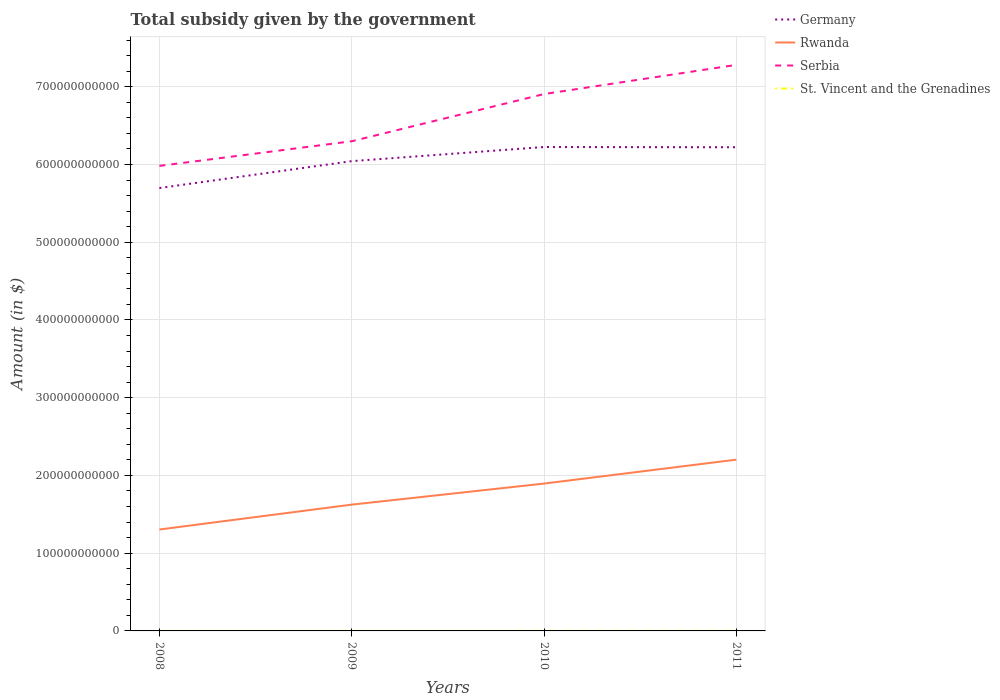How many different coloured lines are there?
Make the answer very short. 4. Does the line corresponding to Rwanda intersect with the line corresponding to Serbia?
Your answer should be very brief. No. Is the number of lines equal to the number of legend labels?
Offer a terse response. Yes. Across all years, what is the maximum total revenue collected by the government in St. Vincent and the Grenadines?
Your answer should be very brief. 8.62e+07. What is the total total revenue collected by the government in St. Vincent and the Grenadines in the graph?
Ensure brevity in your answer.  -2.29e+07. What is the difference between the highest and the second highest total revenue collected by the government in Rwanda?
Your response must be concise. 8.99e+1. What is the difference between the highest and the lowest total revenue collected by the government in Germany?
Your answer should be compact. 2. Is the total revenue collected by the government in Rwanda strictly greater than the total revenue collected by the government in St. Vincent and the Grenadines over the years?
Provide a short and direct response. No. How many lines are there?
Ensure brevity in your answer.  4. What is the difference between two consecutive major ticks on the Y-axis?
Your response must be concise. 1.00e+11. Are the values on the major ticks of Y-axis written in scientific E-notation?
Your answer should be very brief. No. Where does the legend appear in the graph?
Provide a succinct answer. Top right. How are the legend labels stacked?
Your response must be concise. Vertical. What is the title of the graph?
Your answer should be compact. Total subsidy given by the government. What is the label or title of the X-axis?
Offer a terse response. Years. What is the label or title of the Y-axis?
Offer a very short reply. Amount (in $). What is the Amount (in $) in Germany in 2008?
Your answer should be compact. 5.70e+11. What is the Amount (in $) in Rwanda in 2008?
Offer a terse response. 1.30e+11. What is the Amount (in $) of Serbia in 2008?
Your answer should be compact. 5.98e+11. What is the Amount (in $) in St. Vincent and the Grenadines in 2008?
Your answer should be compact. 8.62e+07. What is the Amount (in $) in Germany in 2009?
Provide a short and direct response. 6.04e+11. What is the Amount (in $) of Rwanda in 2009?
Give a very brief answer. 1.62e+11. What is the Amount (in $) in Serbia in 2009?
Offer a terse response. 6.30e+11. What is the Amount (in $) of St. Vincent and the Grenadines in 2009?
Your response must be concise. 1.21e+08. What is the Amount (in $) of Germany in 2010?
Ensure brevity in your answer.  6.22e+11. What is the Amount (in $) of Rwanda in 2010?
Give a very brief answer. 1.90e+11. What is the Amount (in $) in Serbia in 2010?
Your answer should be compact. 6.91e+11. What is the Amount (in $) of St. Vincent and the Grenadines in 2010?
Your answer should be compact. 1.32e+08. What is the Amount (in $) in Germany in 2011?
Ensure brevity in your answer.  6.22e+11. What is the Amount (in $) in Rwanda in 2011?
Keep it short and to the point. 2.20e+11. What is the Amount (in $) in Serbia in 2011?
Provide a short and direct response. 7.28e+11. What is the Amount (in $) in St. Vincent and the Grenadines in 2011?
Give a very brief answer. 1.44e+08. Across all years, what is the maximum Amount (in $) of Germany?
Provide a short and direct response. 6.22e+11. Across all years, what is the maximum Amount (in $) of Rwanda?
Make the answer very short. 2.20e+11. Across all years, what is the maximum Amount (in $) of Serbia?
Ensure brevity in your answer.  7.28e+11. Across all years, what is the maximum Amount (in $) in St. Vincent and the Grenadines?
Ensure brevity in your answer.  1.44e+08. Across all years, what is the minimum Amount (in $) in Germany?
Make the answer very short. 5.70e+11. Across all years, what is the minimum Amount (in $) in Rwanda?
Your response must be concise. 1.30e+11. Across all years, what is the minimum Amount (in $) in Serbia?
Your answer should be very brief. 5.98e+11. Across all years, what is the minimum Amount (in $) of St. Vincent and the Grenadines?
Ensure brevity in your answer.  8.62e+07. What is the total Amount (in $) in Germany in the graph?
Provide a short and direct response. 2.42e+12. What is the total Amount (in $) of Rwanda in the graph?
Your answer should be compact. 7.03e+11. What is the total Amount (in $) in Serbia in the graph?
Offer a terse response. 2.65e+12. What is the total Amount (in $) of St. Vincent and the Grenadines in the graph?
Offer a terse response. 4.82e+08. What is the difference between the Amount (in $) in Germany in 2008 and that in 2009?
Provide a succinct answer. -3.46e+1. What is the difference between the Amount (in $) in Rwanda in 2008 and that in 2009?
Your response must be concise. -3.20e+1. What is the difference between the Amount (in $) in Serbia in 2008 and that in 2009?
Provide a succinct answer. -3.17e+1. What is the difference between the Amount (in $) of St. Vincent and the Grenadines in 2008 and that in 2009?
Ensure brevity in your answer.  -3.45e+07. What is the difference between the Amount (in $) in Germany in 2008 and that in 2010?
Provide a succinct answer. -5.28e+1. What is the difference between the Amount (in $) of Rwanda in 2008 and that in 2010?
Offer a very short reply. -5.91e+1. What is the difference between the Amount (in $) in Serbia in 2008 and that in 2010?
Ensure brevity in your answer.  -9.24e+1. What is the difference between the Amount (in $) of St. Vincent and the Grenadines in 2008 and that in 2010?
Offer a terse response. -4.57e+07. What is the difference between the Amount (in $) in Germany in 2008 and that in 2011?
Provide a short and direct response. -5.25e+1. What is the difference between the Amount (in $) of Rwanda in 2008 and that in 2011?
Keep it short and to the point. -8.99e+1. What is the difference between the Amount (in $) in Serbia in 2008 and that in 2011?
Offer a very short reply. -1.30e+11. What is the difference between the Amount (in $) in St. Vincent and the Grenadines in 2008 and that in 2011?
Ensure brevity in your answer.  -5.74e+07. What is the difference between the Amount (in $) in Germany in 2009 and that in 2010?
Make the answer very short. -1.82e+1. What is the difference between the Amount (in $) of Rwanda in 2009 and that in 2010?
Offer a terse response. -2.71e+1. What is the difference between the Amount (in $) of Serbia in 2009 and that in 2010?
Your answer should be compact. -6.07e+1. What is the difference between the Amount (in $) in St. Vincent and the Grenadines in 2009 and that in 2010?
Give a very brief answer. -1.12e+07. What is the difference between the Amount (in $) of Germany in 2009 and that in 2011?
Ensure brevity in your answer.  -1.79e+1. What is the difference between the Amount (in $) in Rwanda in 2009 and that in 2011?
Your answer should be very brief. -5.79e+1. What is the difference between the Amount (in $) of Serbia in 2009 and that in 2011?
Provide a succinct answer. -9.83e+1. What is the difference between the Amount (in $) in St. Vincent and the Grenadines in 2009 and that in 2011?
Provide a succinct answer. -2.29e+07. What is the difference between the Amount (in $) of Germany in 2010 and that in 2011?
Make the answer very short. 3.00e+08. What is the difference between the Amount (in $) of Rwanda in 2010 and that in 2011?
Provide a short and direct response. -3.08e+1. What is the difference between the Amount (in $) in Serbia in 2010 and that in 2011?
Keep it short and to the point. -3.75e+1. What is the difference between the Amount (in $) of St. Vincent and the Grenadines in 2010 and that in 2011?
Offer a very short reply. -1.17e+07. What is the difference between the Amount (in $) in Germany in 2008 and the Amount (in $) in Rwanda in 2009?
Your response must be concise. 4.07e+11. What is the difference between the Amount (in $) in Germany in 2008 and the Amount (in $) in Serbia in 2009?
Your response must be concise. -6.02e+1. What is the difference between the Amount (in $) in Germany in 2008 and the Amount (in $) in St. Vincent and the Grenadines in 2009?
Your answer should be very brief. 5.70e+11. What is the difference between the Amount (in $) of Rwanda in 2008 and the Amount (in $) of Serbia in 2009?
Offer a very short reply. -4.99e+11. What is the difference between the Amount (in $) in Rwanda in 2008 and the Amount (in $) in St. Vincent and the Grenadines in 2009?
Ensure brevity in your answer.  1.30e+11. What is the difference between the Amount (in $) of Serbia in 2008 and the Amount (in $) of St. Vincent and the Grenadines in 2009?
Make the answer very short. 5.98e+11. What is the difference between the Amount (in $) in Germany in 2008 and the Amount (in $) in Rwanda in 2010?
Offer a very short reply. 3.80e+11. What is the difference between the Amount (in $) of Germany in 2008 and the Amount (in $) of Serbia in 2010?
Your answer should be very brief. -1.21e+11. What is the difference between the Amount (in $) in Germany in 2008 and the Amount (in $) in St. Vincent and the Grenadines in 2010?
Your response must be concise. 5.70e+11. What is the difference between the Amount (in $) in Rwanda in 2008 and the Amount (in $) in Serbia in 2010?
Offer a very short reply. -5.60e+11. What is the difference between the Amount (in $) of Rwanda in 2008 and the Amount (in $) of St. Vincent and the Grenadines in 2010?
Your response must be concise. 1.30e+11. What is the difference between the Amount (in $) of Serbia in 2008 and the Amount (in $) of St. Vincent and the Grenadines in 2010?
Your answer should be very brief. 5.98e+11. What is the difference between the Amount (in $) in Germany in 2008 and the Amount (in $) in Rwanda in 2011?
Provide a short and direct response. 3.49e+11. What is the difference between the Amount (in $) of Germany in 2008 and the Amount (in $) of Serbia in 2011?
Your answer should be very brief. -1.58e+11. What is the difference between the Amount (in $) of Germany in 2008 and the Amount (in $) of St. Vincent and the Grenadines in 2011?
Your answer should be very brief. 5.70e+11. What is the difference between the Amount (in $) in Rwanda in 2008 and the Amount (in $) in Serbia in 2011?
Ensure brevity in your answer.  -5.98e+11. What is the difference between the Amount (in $) in Rwanda in 2008 and the Amount (in $) in St. Vincent and the Grenadines in 2011?
Make the answer very short. 1.30e+11. What is the difference between the Amount (in $) of Serbia in 2008 and the Amount (in $) of St. Vincent and the Grenadines in 2011?
Ensure brevity in your answer.  5.98e+11. What is the difference between the Amount (in $) of Germany in 2009 and the Amount (in $) of Rwanda in 2010?
Keep it short and to the point. 4.15e+11. What is the difference between the Amount (in $) of Germany in 2009 and the Amount (in $) of Serbia in 2010?
Provide a short and direct response. -8.63e+1. What is the difference between the Amount (in $) in Germany in 2009 and the Amount (in $) in St. Vincent and the Grenadines in 2010?
Keep it short and to the point. 6.04e+11. What is the difference between the Amount (in $) in Rwanda in 2009 and the Amount (in $) in Serbia in 2010?
Provide a short and direct response. -5.28e+11. What is the difference between the Amount (in $) in Rwanda in 2009 and the Amount (in $) in St. Vincent and the Grenadines in 2010?
Give a very brief answer. 1.62e+11. What is the difference between the Amount (in $) of Serbia in 2009 and the Amount (in $) of St. Vincent and the Grenadines in 2010?
Give a very brief answer. 6.30e+11. What is the difference between the Amount (in $) in Germany in 2009 and the Amount (in $) in Rwanda in 2011?
Offer a very short reply. 3.84e+11. What is the difference between the Amount (in $) in Germany in 2009 and the Amount (in $) in Serbia in 2011?
Keep it short and to the point. -1.24e+11. What is the difference between the Amount (in $) in Germany in 2009 and the Amount (in $) in St. Vincent and the Grenadines in 2011?
Keep it short and to the point. 6.04e+11. What is the difference between the Amount (in $) in Rwanda in 2009 and the Amount (in $) in Serbia in 2011?
Offer a very short reply. -5.66e+11. What is the difference between the Amount (in $) of Rwanda in 2009 and the Amount (in $) of St. Vincent and the Grenadines in 2011?
Your answer should be compact. 1.62e+11. What is the difference between the Amount (in $) of Serbia in 2009 and the Amount (in $) of St. Vincent and the Grenadines in 2011?
Your answer should be compact. 6.30e+11. What is the difference between the Amount (in $) in Germany in 2010 and the Amount (in $) in Rwanda in 2011?
Your response must be concise. 4.02e+11. What is the difference between the Amount (in $) of Germany in 2010 and the Amount (in $) of Serbia in 2011?
Provide a short and direct response. -1.06e+11. What is the difference between the Amount (in $) of Germany in 2010 and the Amount (in $) of St. Vincent and the Grenadines in 2011?
Keep it short and to the point. 6.22e+11. What is the difference between the Amount (in $) in Rwanda in 2010 and the Amount (in $) in Serbia in 2011?
Your answer should be very brief. -5.39e+11. What is the difference between the Amount (in $) of Rwanda in 2010 and the Amount (in $) of St. Vincent and the Grenadines in 2011?
Offer a very short reply. 1.89e+11. What is the difference between the Amount (in $) in Serbia in 2010 and the Amount (in $) in St. Vincent and the Grenadines in 2011?
Your answer should be compact. 6.90e+11. What is the average Amount (in $) in Germany per year?
Keep it short and to the point. 6.05e+11. What is the average Amount (in $) in Rwanda per year?
Offer a very short reply. 1.76e+11. What is the average Amount (in $) of Serbia per year?
Offer a terse response. 6.62e+11. What is the average Amount (in $) of St. Vincent and the Grenadines per year?
Your answer should be very brief. 1.21e+08. In the year 2008, what is the difference between the Amount (in $) in Germany and Amount (in $) in Rwanda?
Offer a very short reply. 4.39e+11. In the year 2008, what is the difference between the Amount (in $) in Germany and Amount (in $) in Serbia?
Your answer should be compact. -2.85e+1. In the year 2008, what is the difference between the Amount (in $) in Germany and Amount (in $) in St. Vincent and the Grenadines?
Your response must be concise. 5.70e+11. In the year 2008, what is the difference between the Amount (in $) in Rwanda and Amount (in $) in Serbia?
Keep it short and to the point. -4.68e+11. In the year 2008, what is the difference between the Amount (in $) of Rwanda and Amount (in $) of St. Vincent and the Grenadines?
Offer a terse response. 1.30e+11. In the year 2008, what is the difference between the Amount (in $) of Serbia and Amount (in $) of St. Vincent and the Grenadines?
Keep it short and to the point. 5.98e+11. In the year 2009, what is the difference between the Amount (in $) of Germany and Amount (in $) of Rwanda?
Make the answer very short. 4.42e+11. In the year 2009, what is the difference between the Amount (in $) of Germany and Amount (in $) of Serbia?
Provide a succinct answer. -2.56e+1. In the year 2009, what is the difference between the Amount (in $) in Germany and Amount (in $) in St. Vincent and the Grenadines?
Your response must be concise. 6.04e+11. In the year 2009, what is the difference between the Amount (in $) of Rwanda and Amount (in $) of Serbia?
Keep it short and to the point. -4.67e+11. In the year 2009, what is the difference between the Amount (in $) of Rwanda and Amount (in $) of St. Vincent and the Grenadines?
Give a very brief answer. 1.62e+11. In the year 2009, what is the difference between the Amount (in $) of Serbia and Amount (in $) of St. Vincent and the Grenadines?
Offer a terse response. 6.30e+11. In the year 2010, what is the difference between the Amount (in $) in Germany and Amount (in $) in Rwanda?
Ensure brevity in your answer.  4.33e+11. In the year 2010, what is the difference between the Amount (in $) of Germany and Amount (in $) of Serbia?
Your answer should be compact. -6.81e+1. In the year 2010, what is the difference between the Amount (in $) of Germany and Amount (in $) of St. Vincent and the Grenadines?
Offer a terse response. 6.22e+11. In the year 2010, what is the difference between the Amount (in $) of Rwanda and Amount (in $) of Serbia?
Ensure brevity in your answer.  -5.01e+11. In the year 2010, what is the difference between the Amount (in $) of Rwanda and Amount (in $) of St. Vincent and the Grenadines?
Your answer should be very brief. 1.89e+11. In the year 2010, what is the difference between the Amount (in $) in Serbia and Amount (in $) in St. Vincent and the Grenadines?
Your answer should be very brief. 6.90e+11. In the year 2011, what is the difference between the Amount (in $) in Germany and Amount (in $) in Rwanda?
Provide a short and direct response. 4.02e+11. In the year 2011, what is the difference between the Amount (in $) in Germany and Amount (in $) in Serbia?
Your answer should be compact. -1.06e+11. In the year 2011, what is the difference between the Amount (in $) in Germany and Amount (in $) in St. Vincent and the Grenadines?
Offer a terse response. 6.22e+11. In the year 2011, what is the difference between the Amount (in $) of Rwanda and Amount (in $) of Serbia?
Offer a very short reply. -5.08e+11. In the year 2011, what is the difference between the Amount (in $) in Rwanda and Amount (in $) in St. Vincent and the Grenadines?
Make the answer very short. 2.20e+11. In the year 2011, what is the difference between the Amount (in $) in Serbia and Amount (in $) in St. Vincent and the Grenadines?
Your answer should be very brief. 7.28e+11. What is the ratio of the Amount (in $) in Germany in 2008 to that in 2009?
Give a very brief answer. 0.94. What is the ratio of the Amount (in $) in Rwanda in 2008 to that in 2009?
Keep it short and to the point. 0.8. What is the ratio of the Amount (in $) of Serbia in 2008 to that in 2009?
Your answer should be compact. 0.95. What is the ratio of the Amount (in $) in St. Vincent and the Grenadines in 2008 to that in 2009?
Your answer should be compact. 0.71. What is the ratio of the Amount (in $) of Germany in 2008 to that in 2010?
Your response must be concise. 0.92. What is the ratio of the Amount (in $) in Rwanda in 2008 to that in 2010?
Make the answer very short. 0.69. What is the ratio of the Amount (in $) of Serbia in 2008 to that in 2010?
Ensure brevity in your answer.  0.87. What is the ratio of the Amount (in $) of St. Vincent and the Grenadines in 2008 to that in 2010?
Ensure brevity in your answer.  0.65. What is the ratio of the Amount (in $) of Germany in 2008 to that in 2011?
Offer a terse response. 0.92. What is the ratio of the Amount (in $) in Rwanda in 2008 to that in 2011?
Your response must be concise. 0.59. What is the ratio of the Amount (in $) of Serbia in 2008 to that in 2011?
Ensure brevity in your answer.  0.82. What is the ratio of the Amount (in $) of St. Vincent and the Grenadines in 2008 to that in 2011?
Offer a very short reply. 0.6. What is the ratio of the Amount (in $) in Germany in 2009 to that in 2010?
Give a very brief answer. 0.97. What is the ratio of the Amount (in $) of Serbia in 2009 to that in 2010?
Make the answer very short. 0.91. What is the ratio of the Amount (in $) of St. Vincent and the Grenadines in 2009 to that in 2010?
Your answer should be very brief. 0.92. What is the ratio of the Amount (in $) in Germany in 2009 to that in 2011?
Your answer should be very brief. 0.97. What is the ratio of the Amount (in $) of Rwanda in 2009 to that in 2011?
Your answer should be compact. 0.74. What is the ratio of the Amount (in $) of Serbia in 2009 to that in 2011?
Keep it short and to the point. 0.86. What is the ratio of the Amount (in $) in St. Vincent and the Grenadines in 2009 to that in 2011?
Give a very brief answer. 0.84. What is the ratio of the Amount (in $) in Germany in 2010 to that in 2011?
Make the answer very short. 1. What is the ratio of the Amount (in $) of Rwanda in 2010 to that in 2011?
Provide a succinct answer. 0.86. What is the ratio of the Amount (in $) in Serbia in 2010 to that in 2011?
Provide a short and direct response. 0.95. What is the ratio of the Amount (in $) in St. Vincent and the Grenadines in 2010 to that in 2011?
Provide a short and direct response. 0.92. What is the difference between the highest and the second highest Amount (in $) of Germany?
Offer a very short reply. 3.00e+08. What is the difference between the highest and the second highest Amount (in $) of Rwanda?
Give a very brief answer. 3.08e+1. What is the difference between the highest and the second highest Amount (in $) of Serbia?
Give a very brief answer. 3.75e+1. What is the difference between the highest and the second highest Amount (in $) in St. Vincent and the Grenadines?
Your answer should be very brief. 1.17e+07. What is the difference between the highest and the lowest Amount (in $) in Germany?
Offer a very short reply. 5.28e+1. What is the difference between the highest and the lowest Amount (in $) of Rwanda?
Your answer should be compact. 8.99e+1. What is the difference between the highest and the lowest Amount (in $) in Serbia?
Your answer should be very brief. 1.30e+11. What is the difference between the highest and the lowest Amount (in $) of St. Vincent and the Grenadines?
Keep it short and to the point. 5.74e+07. 